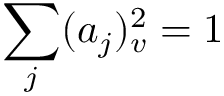Convert formula to latex. <formula><loc_0><loc_0><loc_500><loc_500>\sum _ { j } ( a _ { j } ) _ { v } ^ { 2 } = 1</formula> 